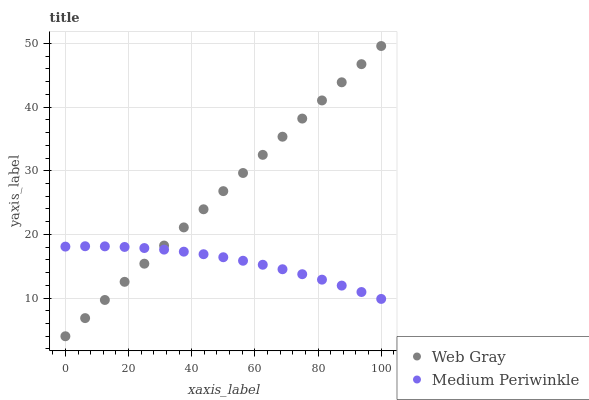Does Medium Periwinkle have the minimum area under the curve?
Answer yes or no. Yes. Does Web Gray have the maximum area under the curve?
Answer yes or no. Yes. Does Medium Periwinkle have the maximum area under the curve?
Answer yes or no. No. Is Web Gray the smoothest?
Answer yes or no. Yes. Is Medium Periwinkle the roughest?
Answer yes or no. Yes. Is Medium Periwinkle the smoothest?
Answer yes or no. No. Does Web Gray have the lowest value?
Answer yes or no. Yes. Does Medium Periwinkle have the lowest value?
Answer yes or no. No. Does Web Gray have the highest value?
Answer yes or no. Yes. Does Medium Periwinkle have the highest value?
Answer yes or no. No. Does Web Gray intersect Medium Periwinkle?
Answer yes or no. Yes. Is Web Gray less than Medium Periwinkle?
Answer yes or no. No. Is Web Gray greater than Medium Periwinkle?
Answer yes or no. No. 